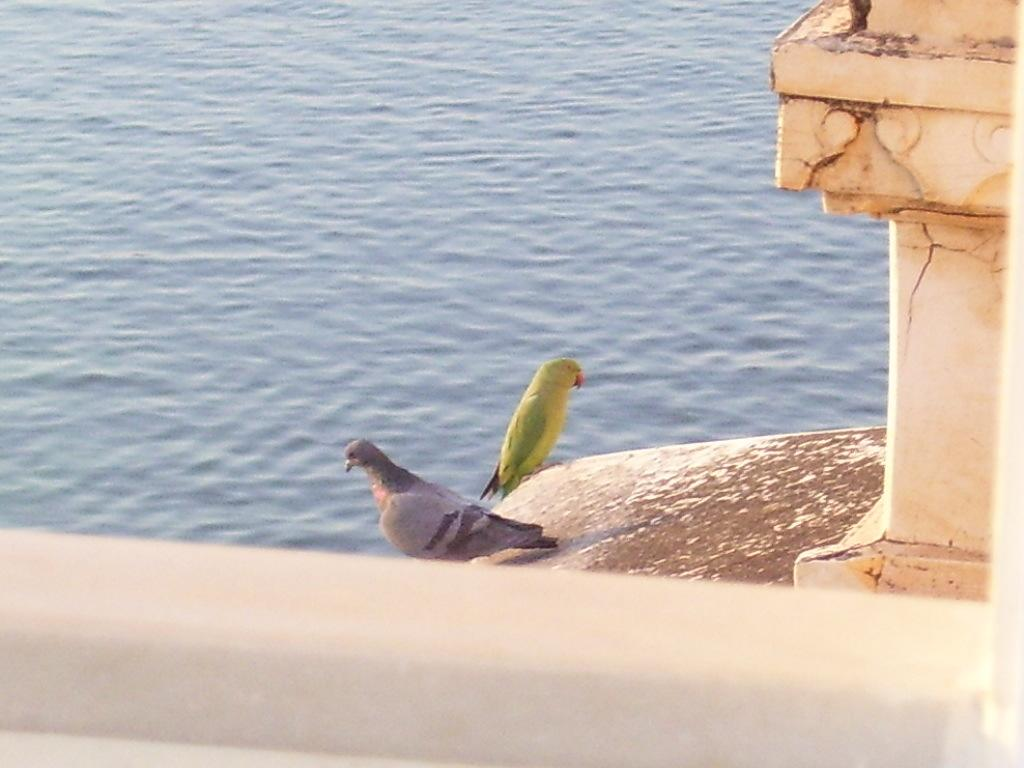What animals can be seen in the foreground of the image? There is a parrot and a pigeon in the foreground of the image. What structure is located on the right side of the image? It appears there is a pillar on the right side of the image. What is at the bottom side of the image? There is a wall at the bottom side of the image. What can be seen in the background of the image? There is water visible in the background of the image. What type of hill can be seen in the background of the image? There is no hill present in the image; it features a parrot, a pigeon, a pillar, a wall, and water in the background. What pets are visible in the image? There are no pets visible in the image, as the parrot and pigeon are wild birds. 